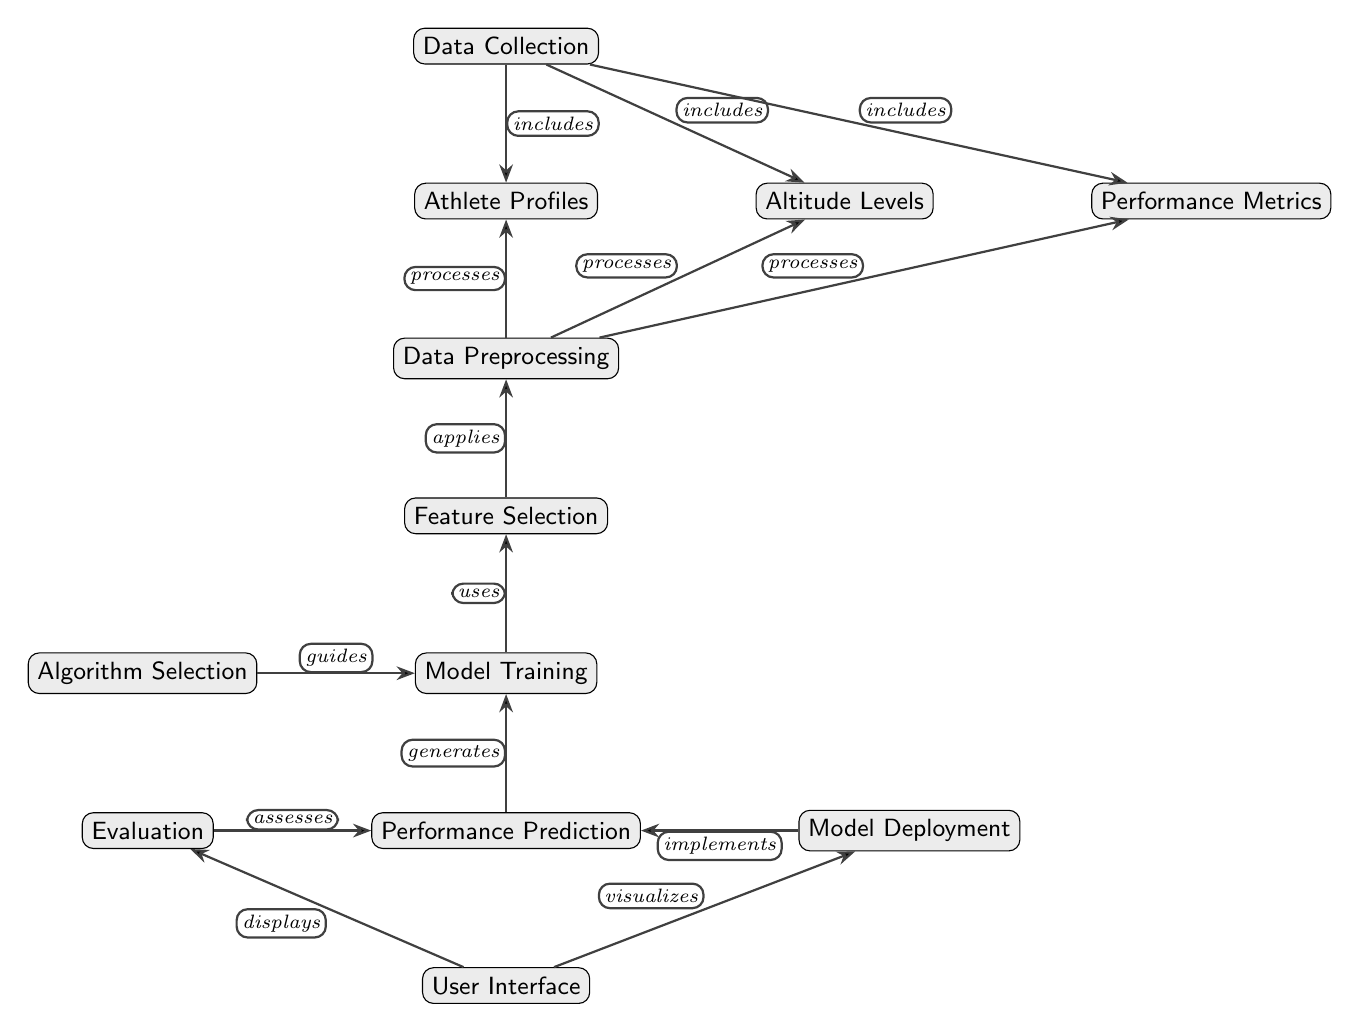What is the first node in the diagram? The first node in the diagram is "Data Collection," which starts the flow of processes represented.
Answer: Data Collection How many nodes are there in total? By counting all distinct nodes in the diagram, we find there are twelve nodes present.
Answer: Twelve Which node comes after Data Preprocessing? The node that comes after "Data Preprocessing" is "Feature Selection," as it directly follows in the processing sequence.
Answer: Feature Selection What relationship exists between Model Training and Algorithm Selection? The relationship between "Model Training" and "Algorithm Selection" is that Algorithm Selection guides the training process for the model.
Answer: Guides Which node processes Athlete Profiles? The node that processes "Athlete Profiles" is "Data Preprocessing," which handles all data input for the model.
Answer: Data Preprocessing What does Performance Prediction generate? "Performance Prediction" generates the outcomes or predictions based on the trained model and selected features.
Answer: Performance Prediction Which node visualizes the output of Model Deployment? The "User Interface" node visualizes the output generated from the "Model Deployment" node for users to interact with.
Answer: User Interface Which nodes have a direct edge pointing to Performance Prediction? "Model Training" directly leads to "Performance Prediction," indicating it's a crucial step in the predictive modeling process.
Answer: Model Training What is the flow direction of the edges in the diagram? The flow direction of the edges in the diagram is generally downward and rightward, following the arrows that connect the nodes.
Answer: Downward and rightward 